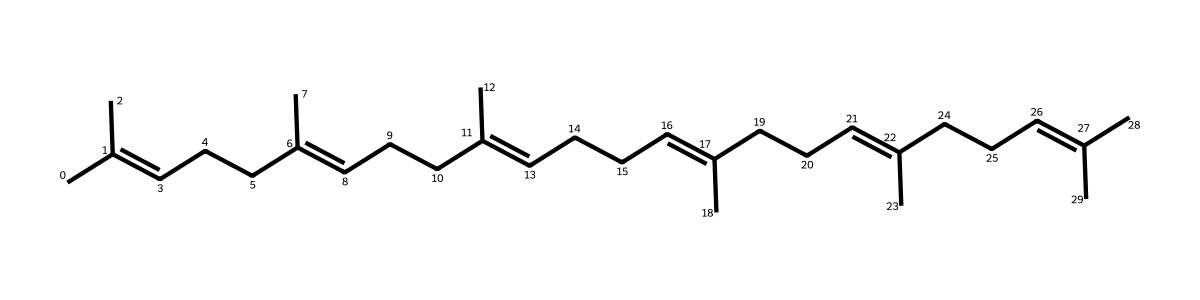What is the name of this chemical? The chemical presented is known as lycopene, which is identified by its unique arrangement of carbon and double bonds as shown in the SMILES representation.
Answer: lycopene How many carbon atoms are in lycopene? To determine the number of carbon atoms, we can count the 'C' present in the SMILES representation. There are 40 carbon atoms in total.
Answer: 40 How many double bonds are in the structure? By examining the structure and identifying each '/' or '\' in the SMILES, we can count the number of double bonds. There are 11 double bonds in the lycopene structure.
Answer: 11 What is the primary role of lycopene? Lycopene functions primarily as an antioxidant, due to its ability to neutralize free radicals and protect cells from oxidative stress.
Answer: antioxidant What type of compound is lycopene classified as? Given its structure, which consists predominantly of carbon and hydrogen with significant unsaturation, lycopene is classified as a carotenoid.
Answer: carotenoid How does the structure of lycopene contribute to its antioxidant properties? The alternating double bonds in lycopene's structure allow it to stabilize free radicals effectively, contributing to its role as an antioxidant.
Answer: alternating double bonds 